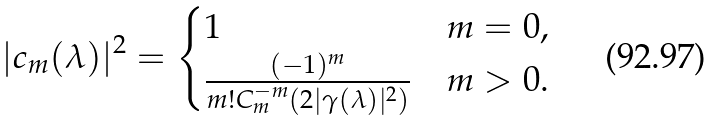<formula> <loc_0><loc_0><loc_500><loc_500>| c _ { m } ( \lambda ) | ^ { 2 } = \begin{cases} 1 & m = 0 , \\ \frac { ( - 1 ) ^ { m } } { m ! C ^ { - m } _ { m } ( 2 | \gamma ( \lambda ) | ^ { 2 } ) } & m > 0 . \end{cases}</formula> 